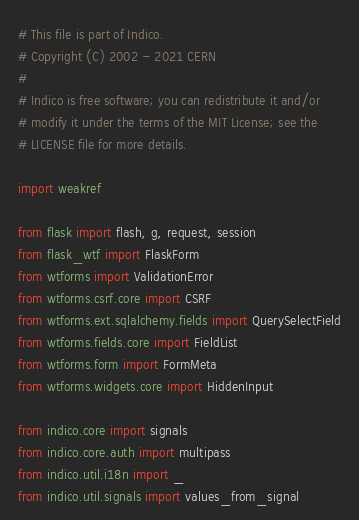<code> <loc_0><loc_0><loc_500><loc_500><_Python_># This file is part of Indico.
# Copyright (C) 2002 - 2021 CERN
#
# Indico is free software; you can redistribute it and/or
# modify it under the terms of the MIT License; see the
# LICENSE file for more details.

import weakref

from flask import flash, g, request, session
from flask_wtf import FlaskForm
from wtforms import ValidationError
from wtforms.csrf.core import CSRF
from wtforms.ext.sqlalchemy.fields import QuerySelectField
from wtforms.fields.core import FieldList
from wtforms.form import FormMeta
from wtforms.widgets.core import HiddenInput

from indico.core import signals
from indico.core.auth import multipass
from indico.util.i18n import _
from indico.util.signals import values_from_signal</code> 